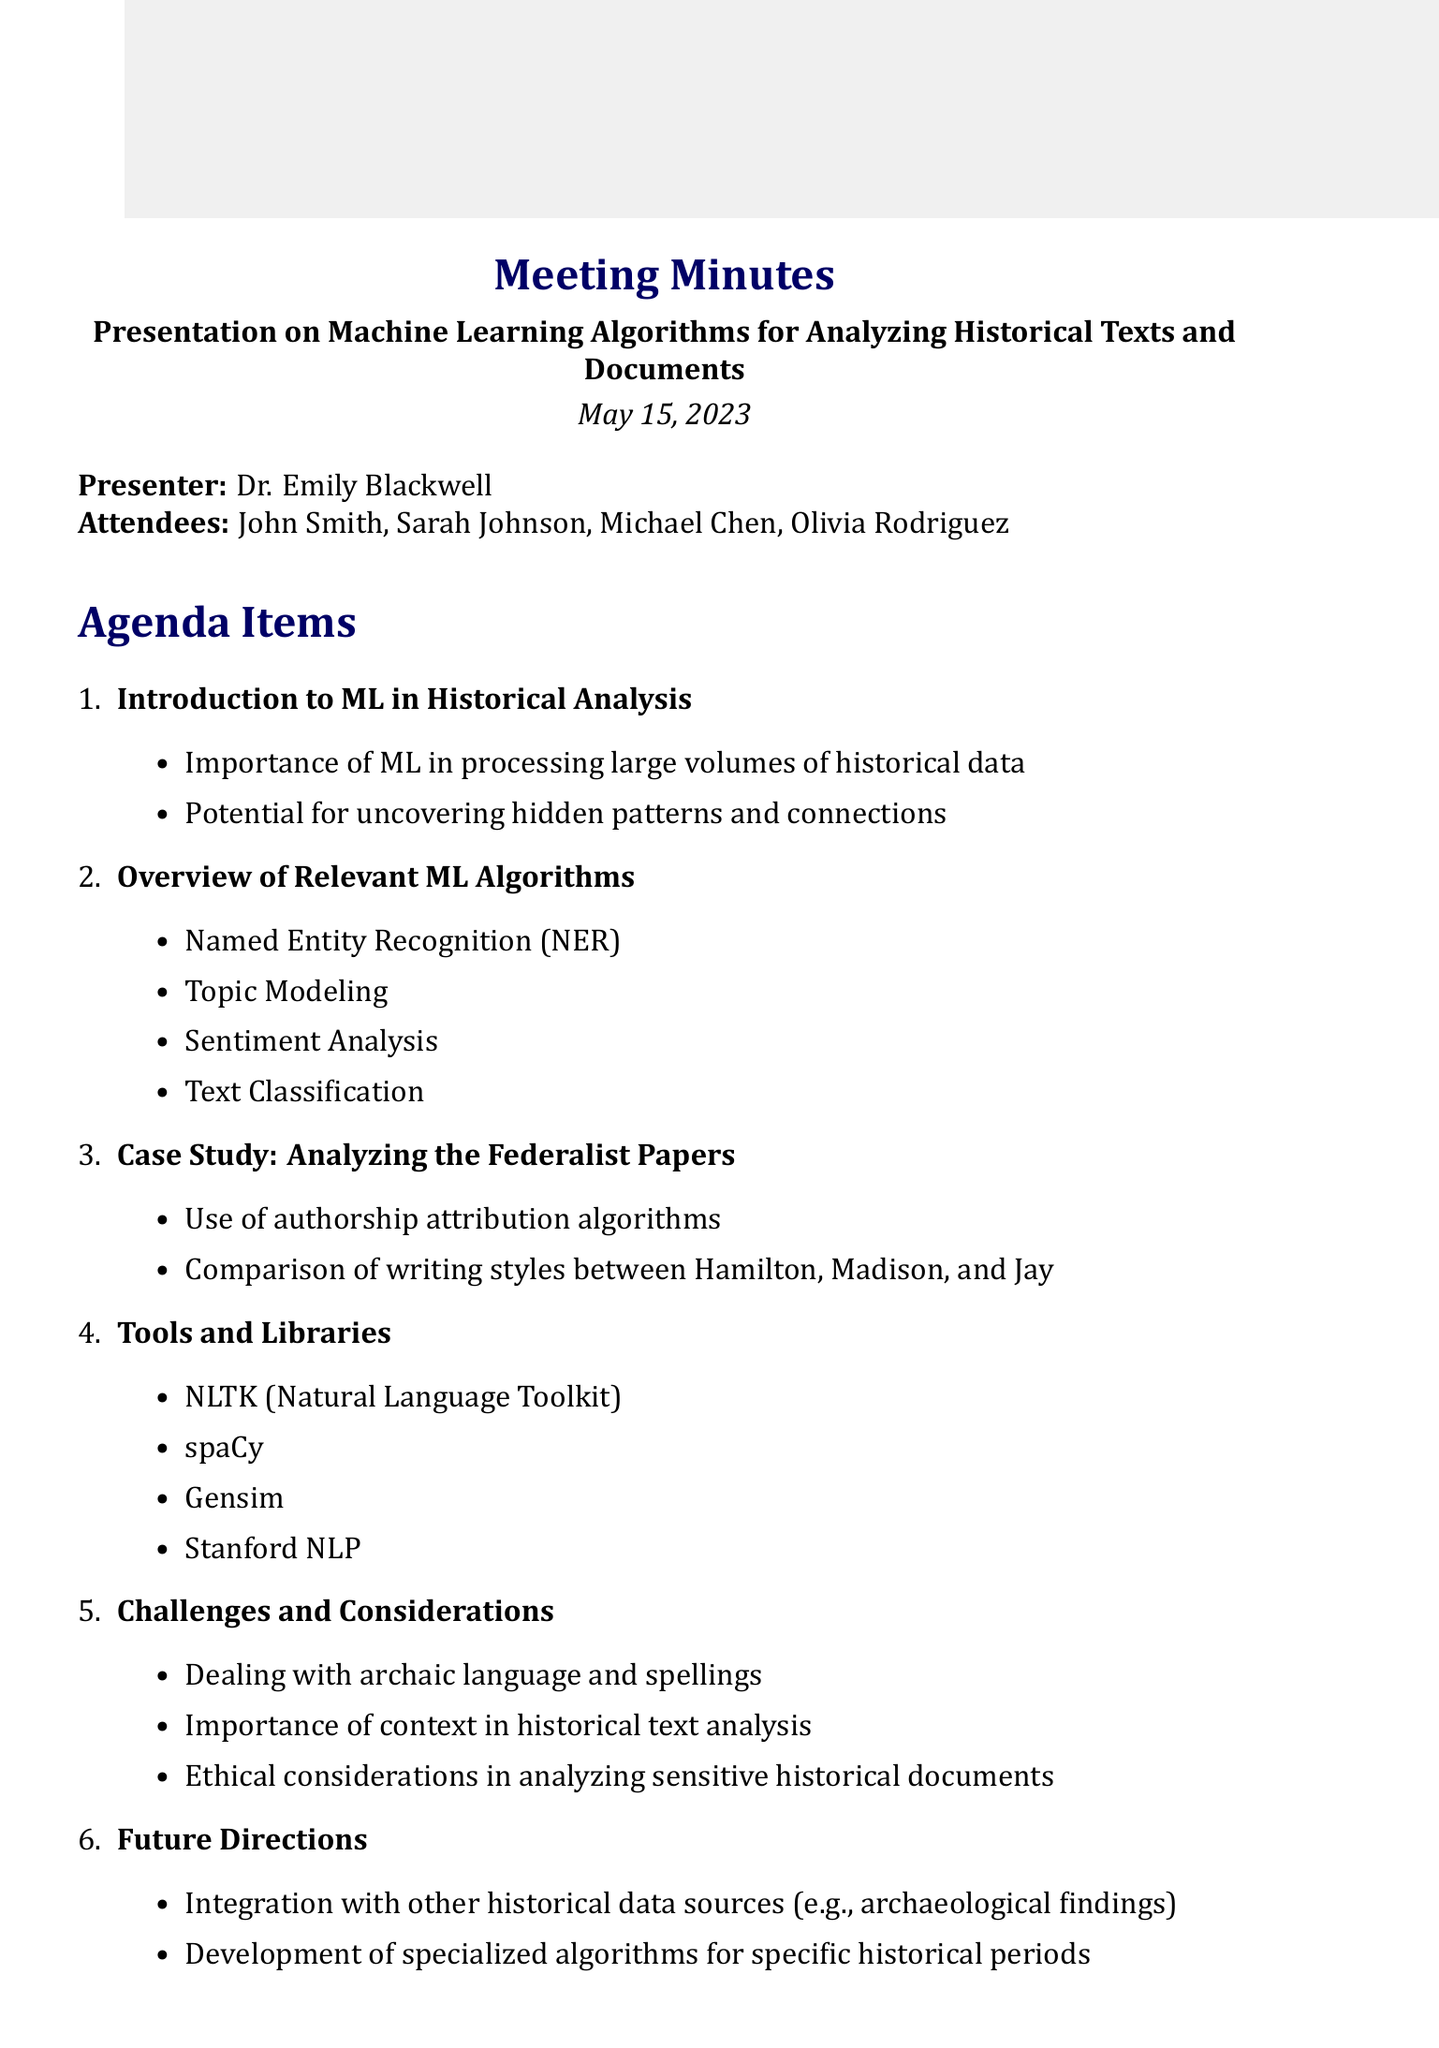what is the date of the meeting? The date of the meeting is mentioned at the top of the document as May 15, 2023.
Answer: May 15, 2023 who presented the meeting? The document states that Dr. Emily Blackwell was the presenter of the meeting.
Answer: Dr. Emily Blackwell what is one of the algorithms discussed in the overview? The document lists several algorithms; one of them is Named Entity Recognition (NER).
Answer: Named Entity Recognition (NER) what case study was presented? The document mentions that the case study presented was about analyzing the Federalist Papers.
Answer: Analyzing the Federalist Papers what is one of the action items? The document includes several action items; one of them is to research potential collaboration with the National Archives.
Answer: Research potential collaboration with the National Archives what are the challenges mentioned in the document? The document lists challenges, one of which includes dealing with archaic language and spellings.
Answer: Dealing with archaic language and spellings how many attendees were present at the meeting? The document lists four attendees: John Smith, Sarah Johnson, Michael Chen, and Olivia Rodriguez.
Answer: Four what is the purpose of machine learning in the context of this meeting? The key points state that the importance of ML is in processing large volumes of historical data.
Answer: Processing large volumes of historical data what future direction is suggested in the document? The document suggests the integration with other historical data sources, such as archaeological findings.
Answer: Integration with other historical data sources 